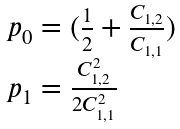<formula> <loc_0><loc_0><loc_500><loc_500>\begin{array} { l } { { p _ { 0 } = ( { \frac { 1 } { 2 } } + { \frac { { C _ { 1 , 2 } } } { { C _ { 1 , 1 } } } } ) } } \\ { { p _ { 1 } = { \frac { { C _ { 1 , 2 } ^ { 2 } } } { { 2 C _ { 1 , 1 } ^ { 2 } } } } } } \end{array}</formula> 